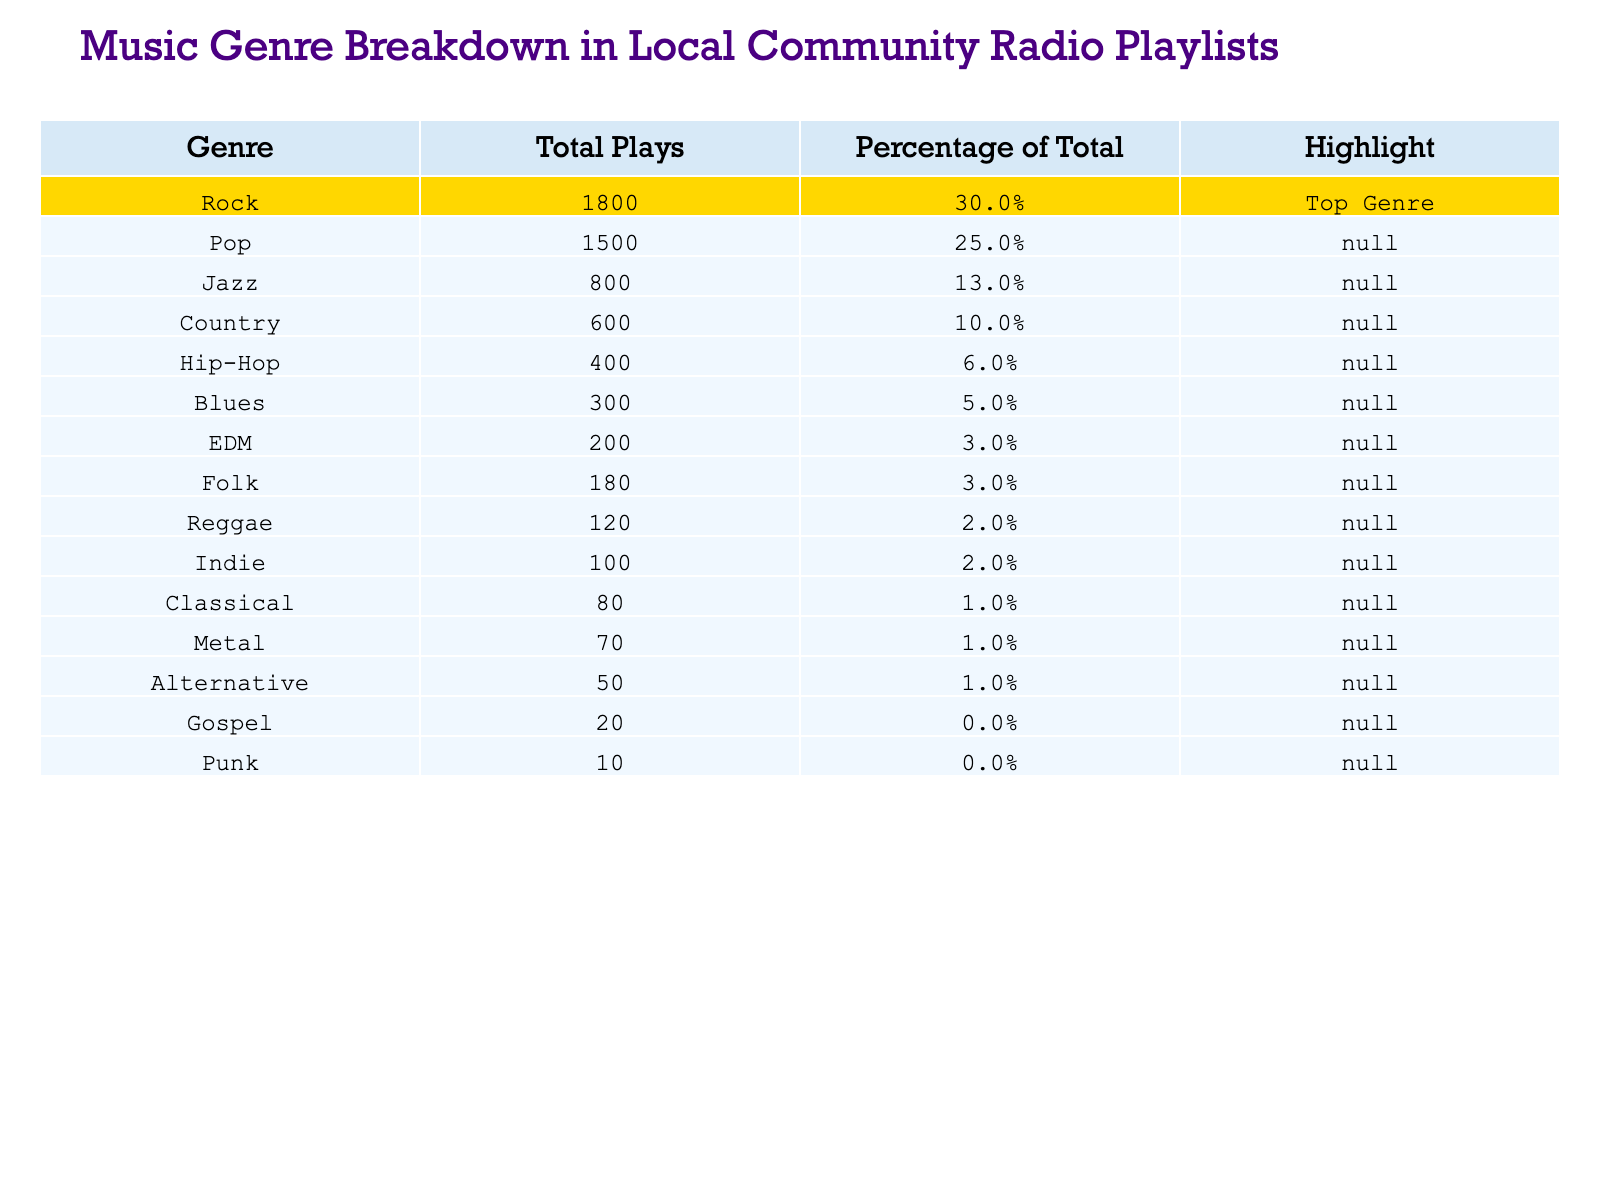What is the top genre played in the local community radio? The table indicates that the genre with the highest total plays is Rock, which has been marked as the "Top Genre".
Answer: Rock How many plays did Pop receive? According to the table, Pop received a total of 1500 plays.
Answer: 1500 What percentage of total plays does Jazz represent? The table shows that Jazz accounts for 13% of the total plays.
Answer: 13% What is the total number of plays for Country and Blues combined? Adding the total plays for Country (600) and Blues (300) results in 600 + 300 = 900.
Answer: 900 Is Hip-Hop more popular than Folk based on total plays? Hip-Hop has 400 plays, while Folk has 180 plays, confirming that Hip-Hop is indeed more popular.
Answer: Yes Which genre has the least number of plays? The table reveals that Punk has the least total plays with only 10.
Answer: Punk What is the difference in total plays between Rock and Country? The total plays for Rock is 1800 and for Country it is 600, resulting in a difference of 1800 - 600 = 1200.
Answer: 1200 If we consider only genres with more than 5% of total plays, how many genres are there? The genres with more than 5% of total plays are Rock, Pop, Jazz, Country, and Hip-Hop, totaling 5 genres.
Answer: 5 What percentage of the total plays do Indie and Classical represent together? Indie has 100 plays (2%) and Classical has 80 plays (1%). Together, they make up 2% + 1% = 3%.
Answer: 3% Is it true that the total plays for EDM and Reggae combined are less than those for Country? EDM has 200 plays and Reggae has 120, making 200 + 120 = 320, which is less than Country's 600 plays, confirming it's true.
Answer: Yes 